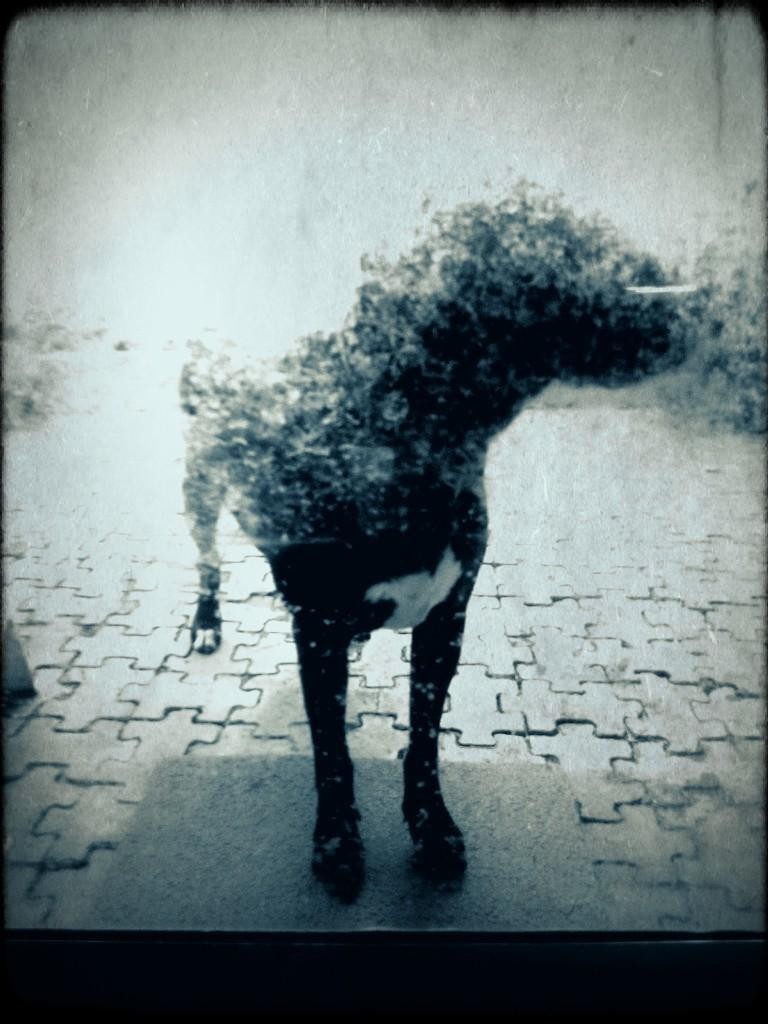What type of animal is present in the image? There is a dog in the image. What color scheme is used for the dog in the image? The dog is in black and white color. What can be seen on the floor in the image? There is a floor mat on the floor in the image. What type of coast can be seen in the background of the image? There is no coast visible in the image; it features a dog and a floor mat. How does the credit card help the dog in the image? There is no credit card present in the image, and therefore it cannot help the dog. 